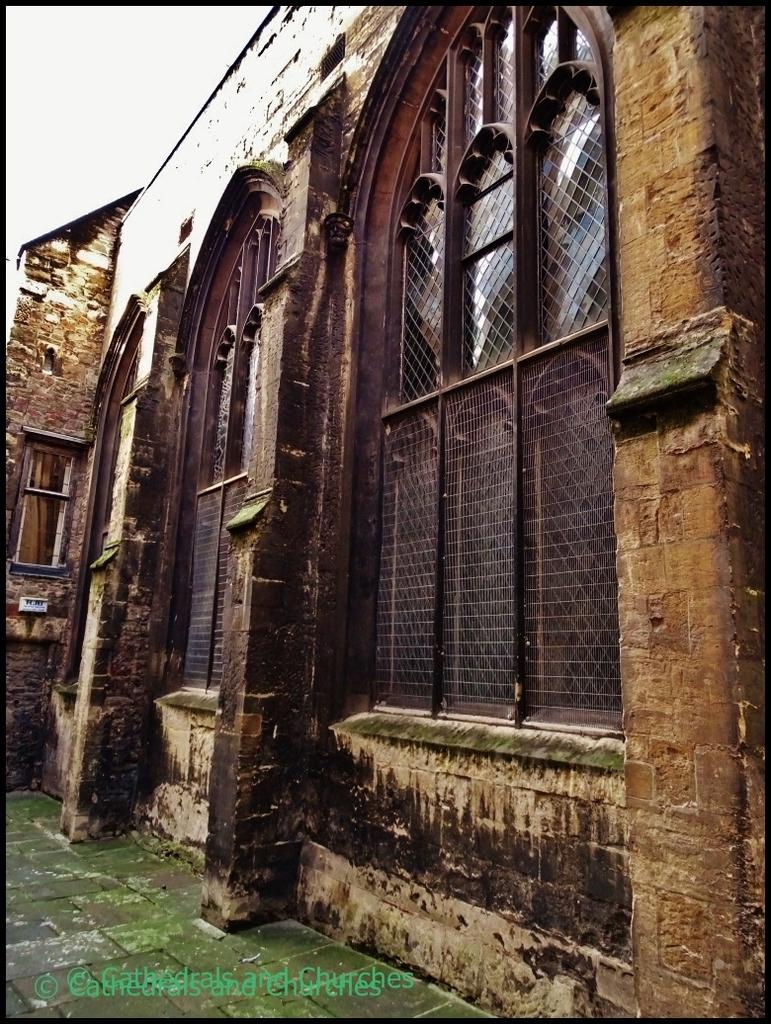What is located in the middle of the image? There is a wall in the middle of the image. What part of the natural environment is visible in the image? The sky is visible in the top left corner of the image. How many bears are wearing mittens in the image? There are no bears or mittens present in the image. 